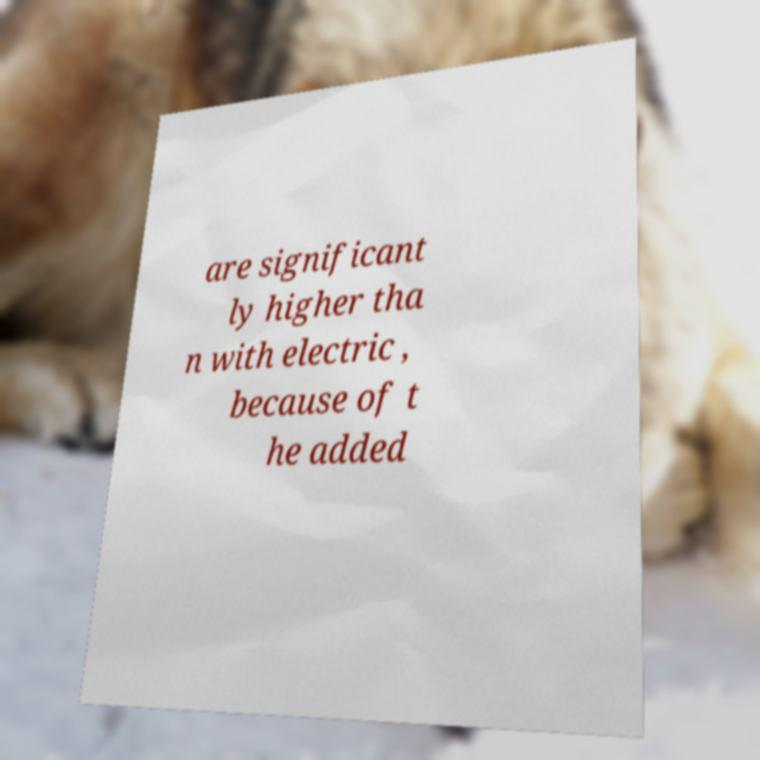There's text embedded in this image that I need extracted. Can you transcribe it verbatim? are significant ly higher tha n with electric , because of t he added 